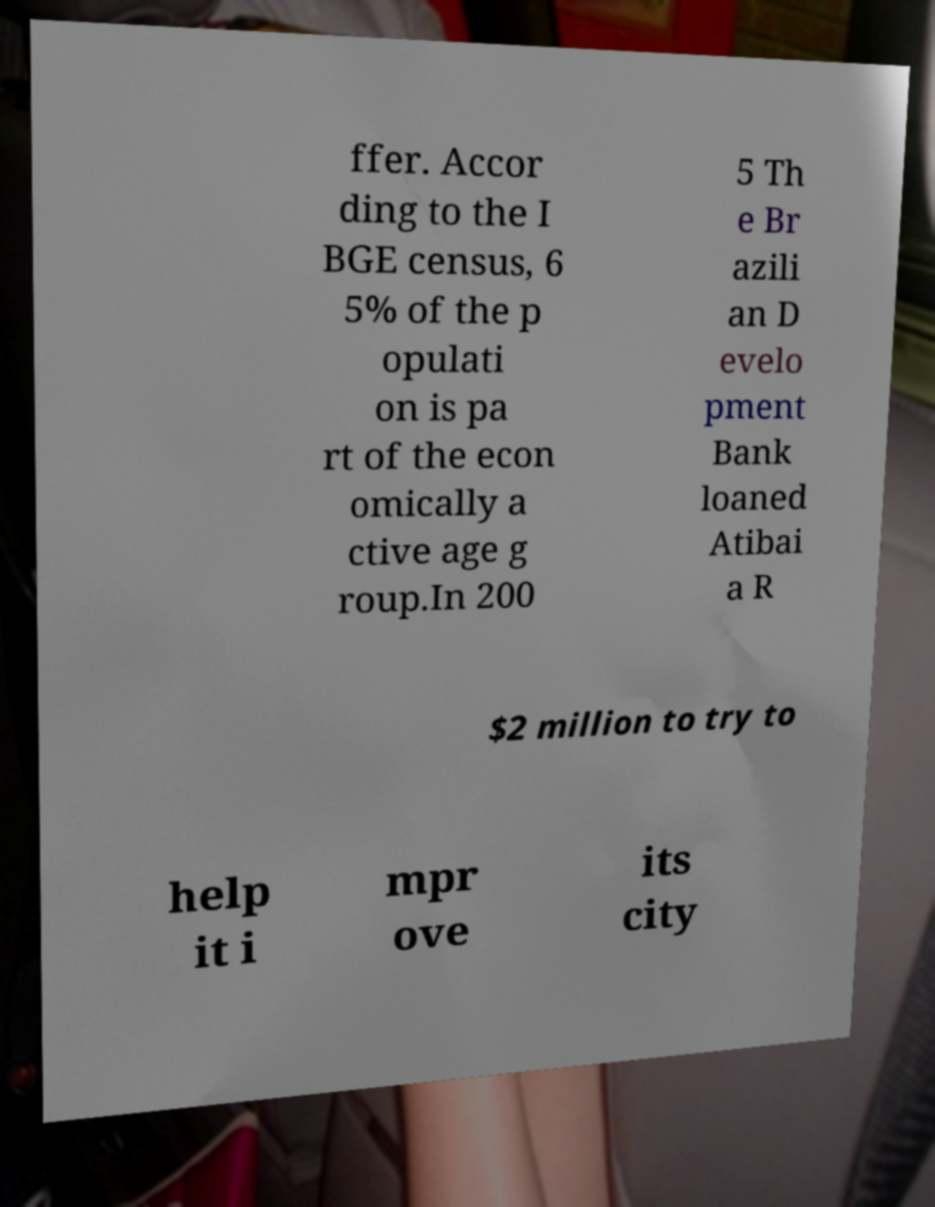There's text embedded in this image that I need extracted. Can you transcribe it verbatim? ffer. Accor ding to the I BGE census, 6 5% of the p opulati on is pa rt of the econ omically a ctive age g roup.In 200 5 Th e Br azili an D evelo pment Bank loaned Atibai a R $2 million to try to help it i mpr ove its city 